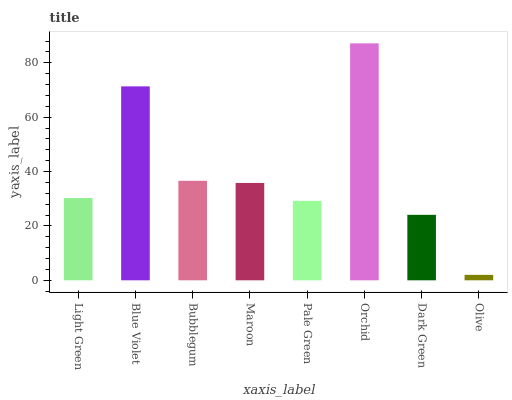Is Olive the minimum?
Answer yes or no. Yes. Is Orchid the maximum?
Answer yes or no. Yes. Is Blue Violet the minimum?
Answer yes or no. No. Is Blue Violet the maximum?
Answer yes or no. No. Is Blue Violet greater than Light Green?
Answer yes or no. Yes. Is Light Green less than Blue Violet?
Answer yes or no. Yes. Is Light Green greater than Blue Violet?
Answer yes or no. No. Is Blue Violet less than Light Green?
Answer yes or no. No. Is Maroon the high median?
Answer yes or no. Yes. Is Light Green the low median?
Answer yes or no. Yes. Is Olive the high median?
Answer yes or no. No. Is Maroon the low median?
Answer yes or no. No. 